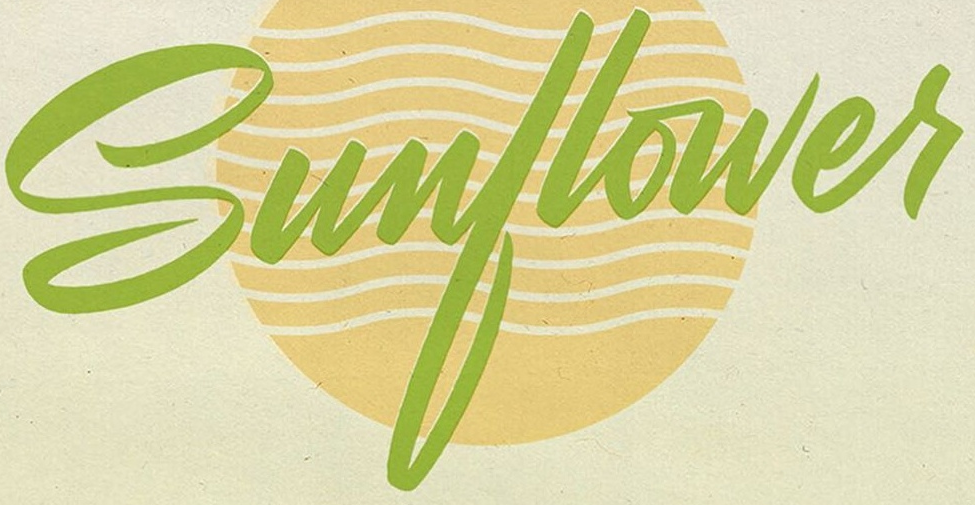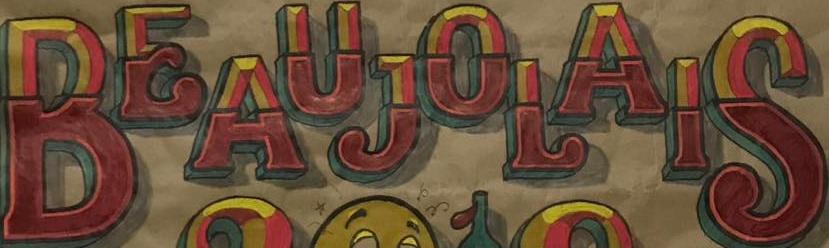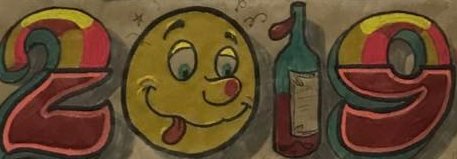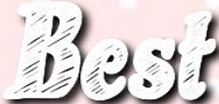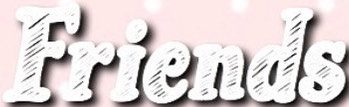What text appears in these images from left to right, separated by a semicolon? Sunflowes; BEAUJOLAIS; 2019; Best; Friends 